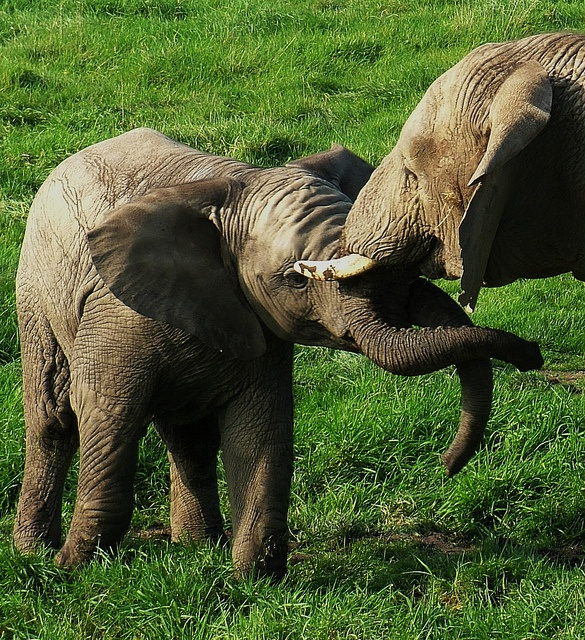Describe the objects in this image and their specific colors. I can see elephant in darkgreen, black, tan, and gray tones and elephant in darkgreen, black, and tan tones in this image. 